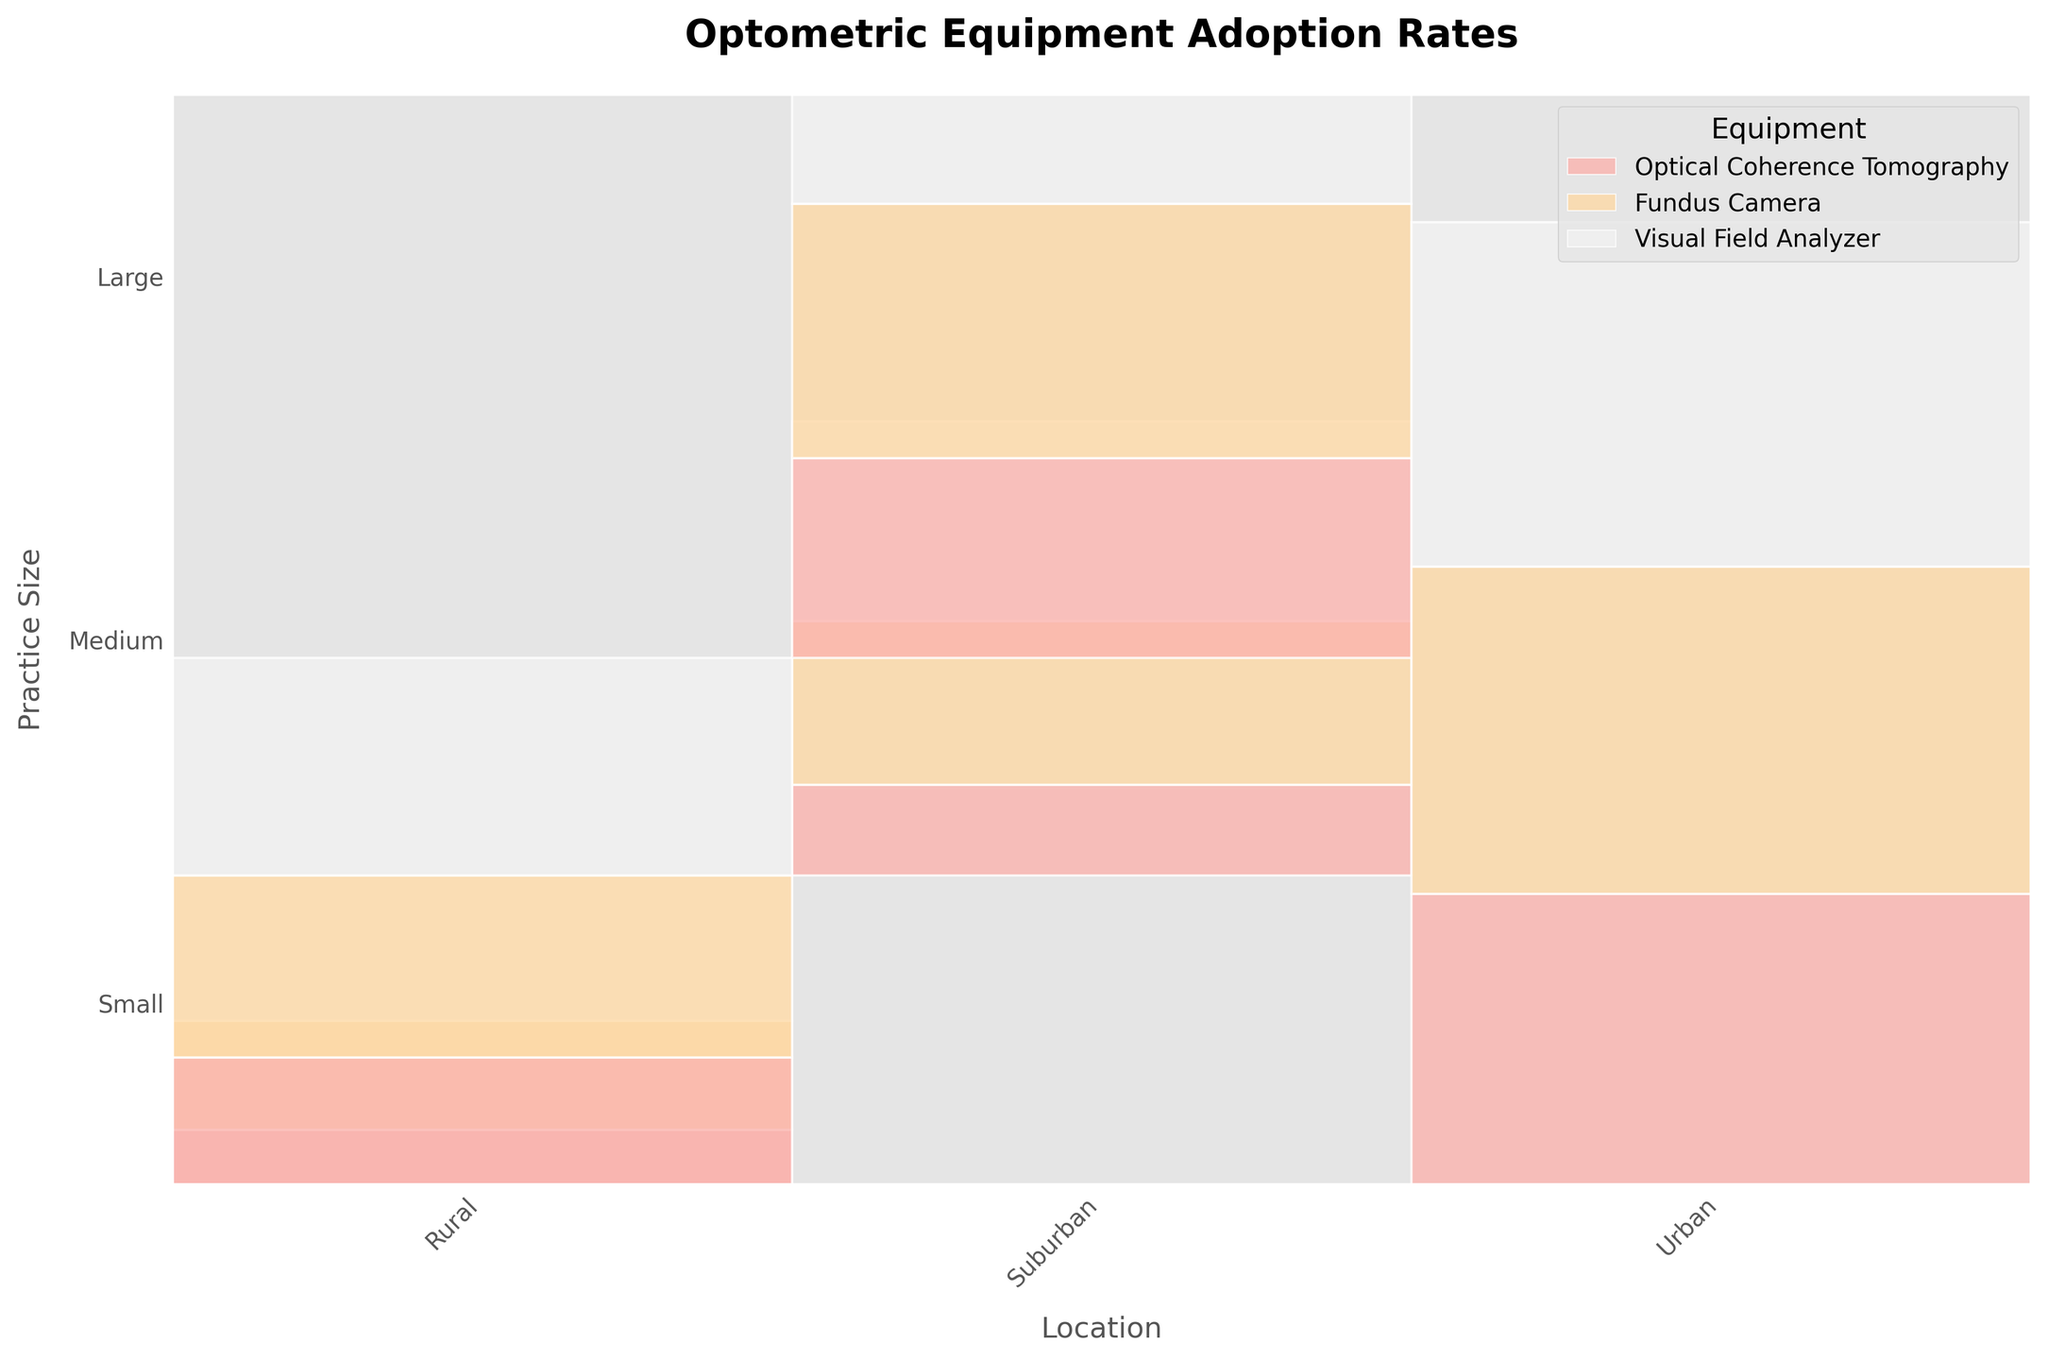What's the title of the mosaic plot? The title is usually located at the top of the figure. It provides an overview of what the plot represents.
Answer: Optometric Equipment Adoption Rates Which equipment has the highest adoption rate across all practice sizes and locations? The legend helps identify which color corresponds to which equipment. The largest rectangles representing each practice size and location should be examined to find the highest value.
Answer: Visual Field Analyzer How does the adoption rate of Optical Coherence Tomography in medium, suburban practices compare to small, rural practices? First, locate the rectangles corresponding to Optical Coherence Tomography in medium, suburban practices and small, rural practices. Then compare the heights of these two rectangles.
Answer: Higher in medium, suburban practices Which practice size has the most varied adoption rates of different equipment types? Look for the practice size where the heights of the rectangles vary the most. This visual difference will indicate a high variability in adoption rates.
Answer: Small What is the total adoption rate of all equipment types in large, urban practices? Sum the heights of all rectangles in the column corresponding to large, urban practices.
Answer: 100% How does the adoption rate of Fundus Cameras change from small, suburban to medium, suburban practices? Locate the rectangles corresponding to Fundus Cameras in small, suburban and medium, suburban practices. Compare the heights to determine the change.
Answer: Increases Are there any practice sizes in rural areas with the highest adoption rates for all three types of equipment? Look for a single practice size in rural areas where the combined height of all three rectangles (Optical Coherence Tomography, Fundus Camera, Visual Field Analyzer) is the highest among other practice sizes.
Answer: No Which location has the least adoption rate for Optical Coherence Tomography regardless of practice size? Check the rectangles representing Optical Coherence Tomography for each location and compare their heights.
Answer: Rural What is the difference in Visual Field Analyzer adoption rates between medium, rural and large, urban practices? Locate the rectangles representing Visual Field Analyzer in medium, rural, and large, urban practices. Subtract the medium, rural rate from the large, urban rate.
Answer: 35% What is the predominant equipment type in small, suburban practices? Identify the tallest rectangle in small, suburban practices to see which equipment type predominates.
Answer: Visual Field Analyzer 